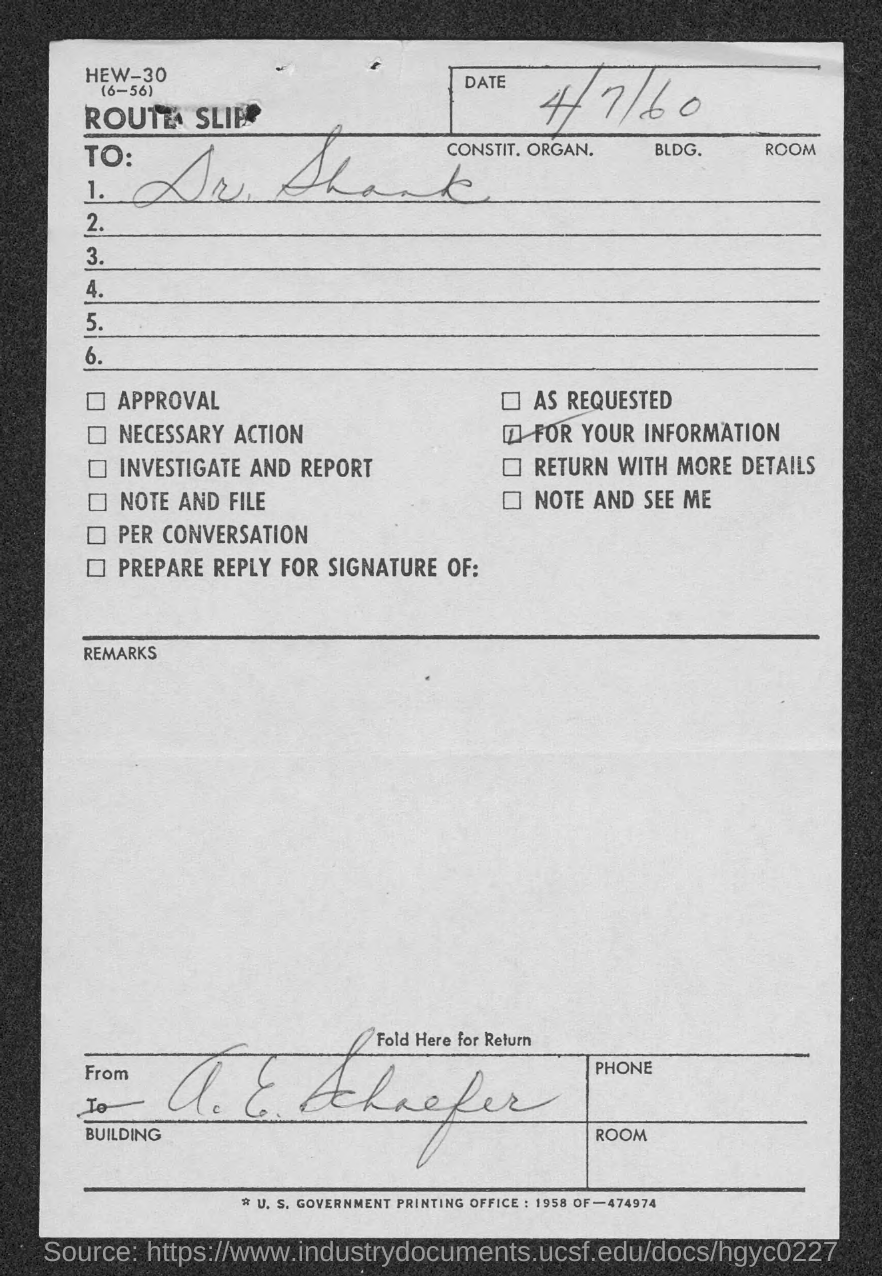Indicate a few pertinent items in this graphic. The date mentioned on the route slip is April 7th, 1960. The route slip is addressed to Dr. Shank. 